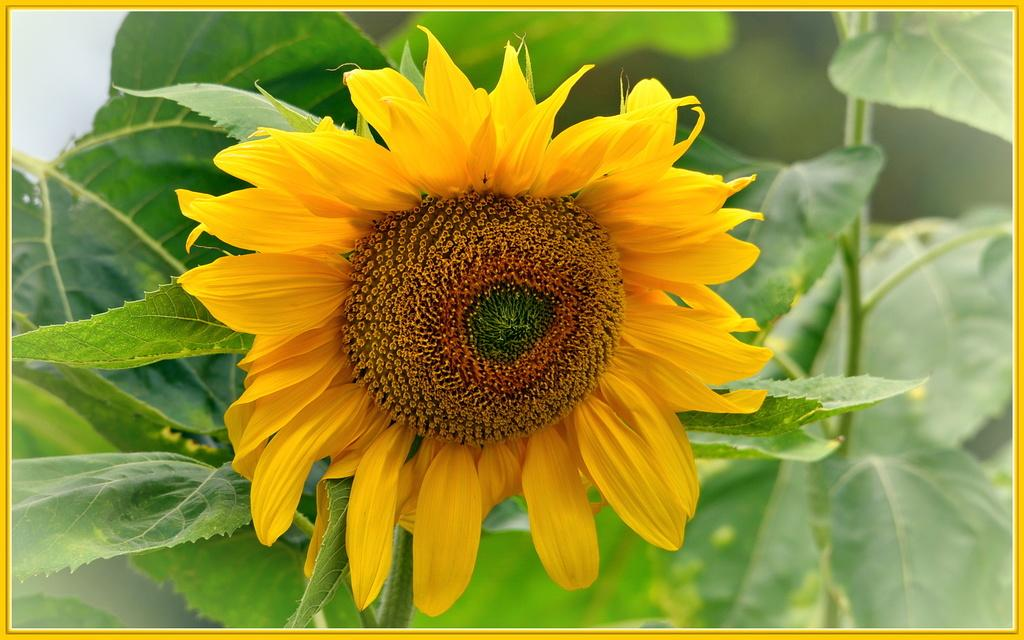What type of plant is in the image? There is a sunflower in the image. What color are the petals of the sunflower? The sunflower has yellow petals. What other parts of the sunflower can be seen in the image? The sunflower has leaves and a stem. What type of yarn is being traded in the image? There is no yarn or trading activity present in the image; it features a sunflower with yellow petals, leaves, and a stem. 